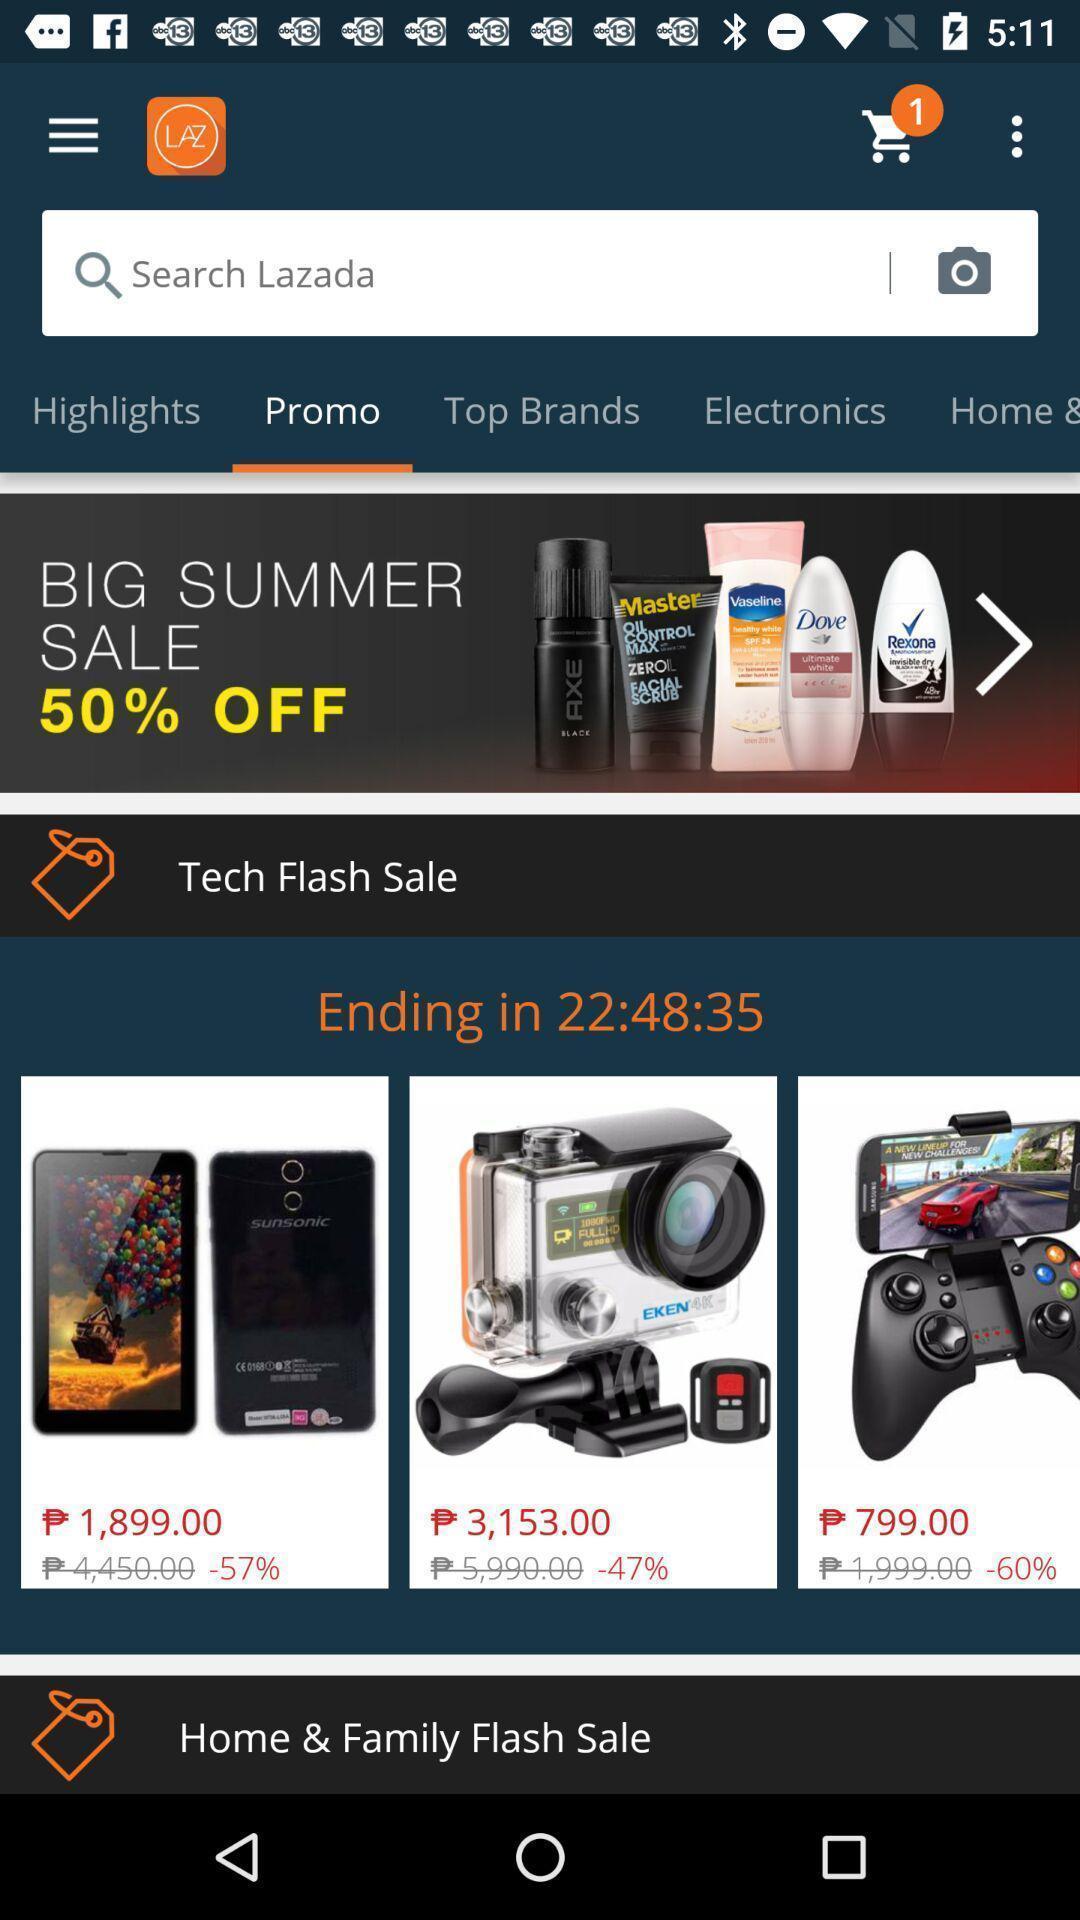What details can you identify in this image? Screen displaying the page of shopping app. 